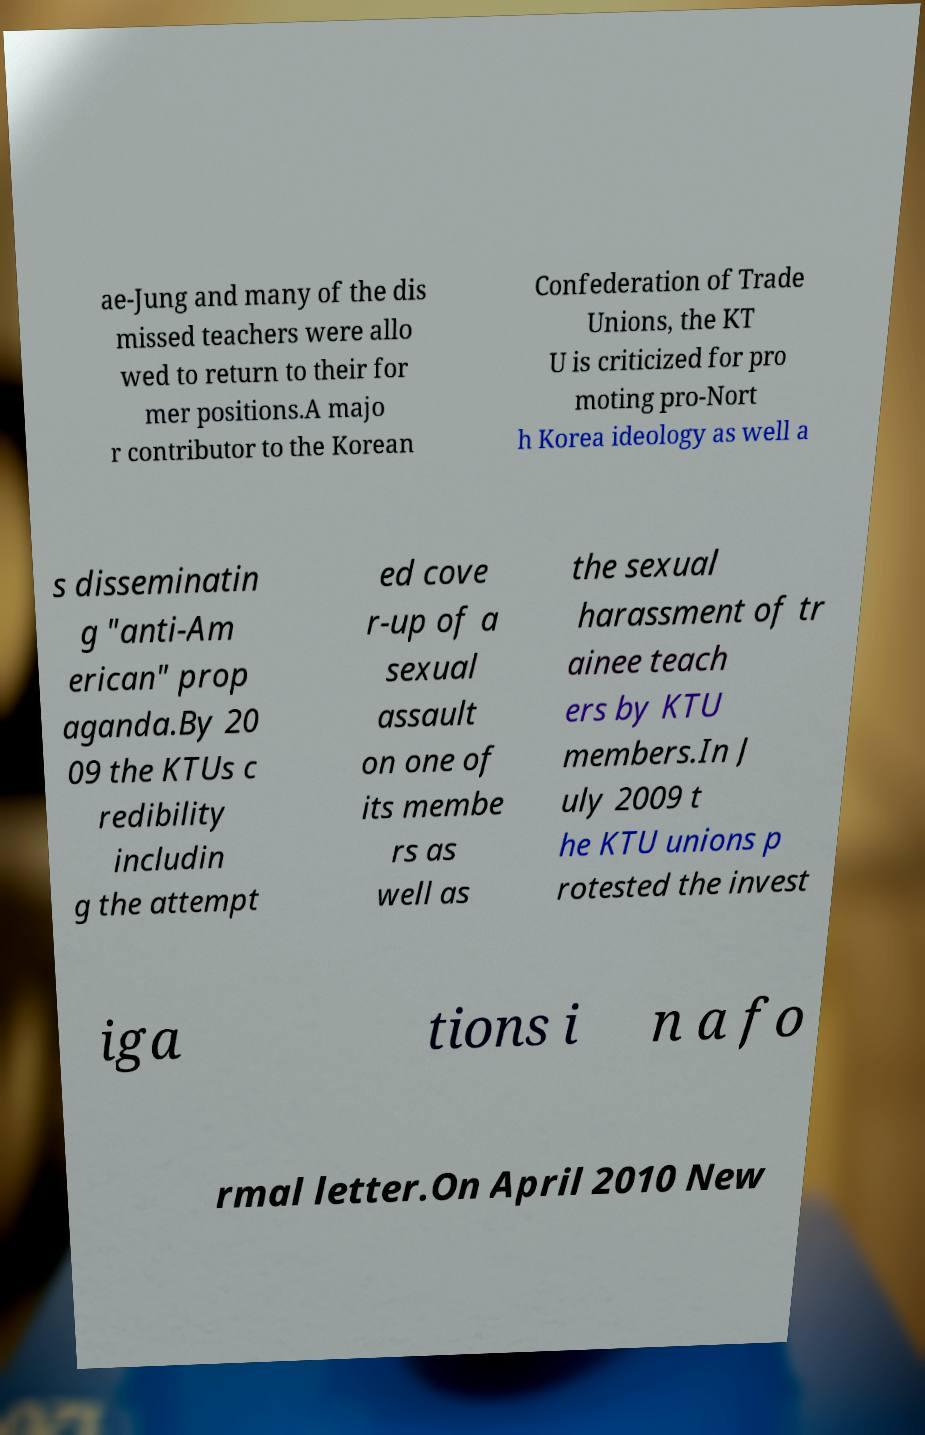What messages or text are displayed in this image? I need them in a readable, typed format. ae-Jung and many of the dis missed teachers were allo wed to return to their for mer positions.A majo r contributor to the Korean Confederation of Trade Unions, the KT U is criticized for pro moting pro-Nort h Korea ideology as well a s disseminatin g "anti-Am erican" prop aganda.By 20 09 the KTUs c redibility includin g the attempt ed cove r-up of a sexual assault on one of its membe rs as well as the sexual harassment of tr ainee teach ers by KTU members.In J uly 2009 t he KTU unions p rotested the invest iga tions i n a fo rmal letter.On April 2010 New 